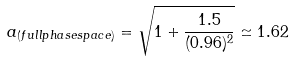<formula> <loc_0><loc_0><loc_500><loc_500>a _ { ( f u l l p h a s e s p a c e ) } = \sqrt { 1 + \frac { 1 . 5 } { ( 0 . 9 6 ) ^ { 2 } } } \simeq 1 . 6 2</formula> 